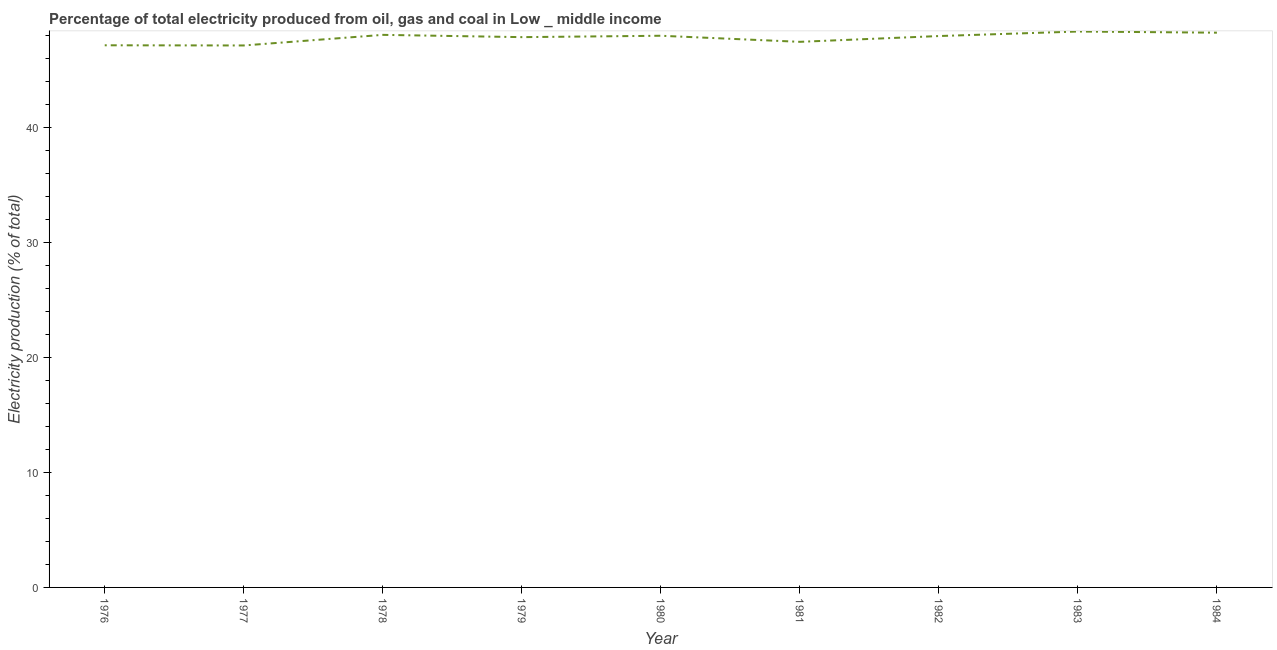What is the electricity production in 1981?
Give a very brief answer. 47.49. Across all years, what is the maximum electricity production?
Provide a succinct answer. 48.39. Across all years, what is the minimum electricity production?
Your response must be concise. 47.17. In which year was the electricity production minimum?
Your answer should be very brief. 1977. What is the sum of the electricity production?
Provide a succinct answer. 430.52. What is the difference between the electricity production in 1978 and 1983?
Your answer should be compact. -0.29. What is the average electricity production per year?
Make the answer very short. 47.84. What is the median electricity production?
Your response must be concise. 47.99. In how many years, is the electricity production greater than 44 %?
Give a very brief answer. 9. What is the ratio of the electricity production in 1980 to that in 1983?
Give a very brief answer. 0.99. Is the electricity production in 1976 less than that in 1984?
Your answer should be compact. Yes. Is the difference between the electricity production in 1976 and 1980 greater than the difference between any two years?
Your answer should be very brief. No. What is the difference between the highest and the second highest electricity production?
Your answer should be very brief. 0.1. Is the sum of the electricity production in 1977 and 1984 greater than the maximum electricity production across all years?
Give a very brief answer. Yes. What is the difference between the highest and the lowest electricity production?
Ensure brevity in your answer.  1.21. In how many years, is the electricity production greater than the average electricity production taken over all years?
Offer a very short reply. 6. Does the electricity production monotonically increase over the years?
Your answer should be very brief. No. What is the difference between two consecutive major ticks on the Y-axis?
Offer a terse response. 10. Does the graph contain grids?
Your answer should be very brief. No. What is the title of the graph?
Your answer should be very brief. Percentage of total electricity produced from oil, gas and coal in Low _ middle income. What is the label or title of the X-axis?
Ensure brevity in your answer.  Year. What is the label or title of the Y-axis?
Offer a very short reply. Electricity production (% of total). What is the Electricity production (% of total) in 1976?
Offer a very short reply. 47.19. What is the Electricity production (% of total) of 1977?
Keep it short and to the point. 47.17. What is the Electricity production (% of total) in 1978?
Ensure brevity in your answer.  48.09. What is the Electricity production (% of total) of 1979?
Ensure brevity in your answer.  47.9. What is the Electricity production (% of total) of 1980?
Give a very brief answer. 48.02. What is the Electricity production (% of total) in 1981?
Provide a succinct answer. 47.49. What is the Electricity production (% of total) in 1982?
Ensure brevity in your answer.  47.99. What is the Electricity production (% of total) in 1983?
Make the answer very short. 48.39. What is the Electricity production (% of total) of 1984?
Offer a very short reply. 48.28. What is the difference between the Electricity production (% of total) in 1976 and 1977?
Your response must be concise. 0.02. What is the difference between the Electricity production (% of total) in 1976 and 1978?
Your response must be concise. -0.91. What is the difference between the Electricity production (% of total) in 1976 and 1979?
Offer a very short reply. -0.71. What is the difference between the Electricity production (% of total) in 1976 and 1980?
Offer a very short reply. -0.83. What is the difference between the Electricity production (% of total) in 1976 and 1981?
Your answer should be very brief. -0.3. What is the difference between the Electricity production (% of total) in 1976 and 1982?
Your response must be concise. -0.8. What is the difference between the Electricity production (% of total) in 1976 and 1983?
Your response must be concise. -1.2. What is the difference between the Electricity production (% of total) in 1976 and 1984?
Your answer should be compact. -1.1. What is the difference between the Electricity production (% of total) in 1977 and 1978?
Your response must be concise. -0.92. What is the difference between the Electricity production (% of total) in 1977 and 1979?
Your answer should be very brief. -0.72. What is the difference between the Electricity production (% of total) in 1977 and 1980?
Ensure brevity in your answer.  -0.85. What is the difference between the Electricity production (% of total) in 1977 and 1981?
Offer a terse response. -0.32. What is the difference between the Electricity production (% of total) in 1977 and 1982?
Your answer should be compact. -0.82. What is the difference between the Electricity production (% of total) in 1977 and 1983?
Make the answer very short. -1.21. What is the difference between the Electricity production (% of total) in 1977 and 1984?
Make the answer very short. -1.11. What is the difference between the Electricity production (% of total) in 1978 and 1979?
Offer a terse response. 0.2. What is the difference between the Electricity production (% of total) in 1978 and 1980?
Make the answer very short. 0.08. What is the difference between the Electricity production (% of total) in 1978 and 1981?
Ensure brevity in your answer.  0.61. What is the difference between the Electricity production (% of total) in 1978 and 1982?
Keep it short and to the point. 0.1. What is the difference between the Electricity production (% of total) in 1978 and 1983?
Make the answer very short. -0.29. What is the difference between the Electricity production (% of total) in 1978 and 1984?
Keep it short and to the point. -0.19. What is the difference between the Electricity production (% of total) in 1979 and 1980?
Give a very brief answer. -0.12. What is the difference between the Electricity production (% of total) in 1979 and 1981?
Keep it short and to the point. 0.41. What is the difference between the Electricity production (% of total) in 1979 and 1982?
Your answer should be very brief. -0.1. What is the difference between the Electricity production (% of total) in 1979 and 1983?
Provide a succinct answer. -0.49. What is the difference between the Electricity production (% of total) in 1979 and 1984?
Give a very brief answer. -0.39. What is the difference between the Electricity production (% of total) in 1980 and 1981?
Provide a short and direct response. 0.53. What is the difference between the Electricity production (% of total) in 1980 and 1982?
Your answer should be compact. 0.03. What is the difference between the Electricity production (% of total) in 1980 and 1983?
Your answer should be compact. -0.37. What is the difference between the Electricity production (% of total) in 1980 and 1984?
Your answer should be compact. -0.27. What is the difference between the Electricity production (% of total) in 1981 and 1982?
Offer a terse response. -0.5. What is the difference between the Electricity production (% of total) in 1981 and 1983?
Make the answer very short. -0.9. What is the difference between the Electricity production (% of total) in 1981 and 1984?
Offer a very short reply. -0.8. What is the difference between the Electricity production (% of total) in 1982 and 1983?
Offer a very short reply. -0.39. What is the difference between the Electricity production (% of total) in 1982 and 1984?
Your answer should be compact. -0.29. What is the difference between the Electricity production (% of total) in 1983 and 1984?
Your answer should be compact. 0.1. What is the ratio of the Electricity production (% of total) in 1976 to that in 1979?
Ensure brevity in your answer.  0.98. What is the ratio of the Electricity production (% of total) in 1976 to that in 1980?
Your answer should be compact. 0.98. What is the ratio of the Electricity production (% of total) in 1976 to that in 1982?
Provide a short and direct response. 0.98. What is the ratio of the Electricity production (% of total) in 1976 to that in 1984?
Your answer should be very brief. 0.98. What is the ratio of the Electricity production (% of total) in 1977 to that in 1979?
Offer a terse response. 0.98. What is the ratio of the Electricity production (% of total) in 1977 to that in 1981?
Make the answer very short. 0.99. What is the ratio of the Electricity production (% of total) in 1977 to that in 1983?
Provide a short and direct response. 0.97. What is the ratio of the Electricity production (% of total) in 1978 to that in 1979?
Ensure brevity in your answer.  1. What is the ratio of the Electricity production (% of total) in 1978 to that in 1981?
Make the answer very short. 1.01. What is the ratio of the Electricity production (% of total) in 1978 to that in 1983?
Provide a short and direct response. 0.99. What is the ratio of the Electricity production (% of total) in 1979 to that in 1981?
Make the answer very short. 1.01. What is the ratio of the Electricity production (% of total) in 1979 to that in 1982?
Provide a short and direct response. 1. What is the ratio of the Electricity production (% of total) in 1979 to that in 1983?
Give a very brief answer. 0.99. What is the ratio of the Electricity production (% of total) in 1980 to that in 1981?
Offer a very short reply. 1.01. What is the ratio of the Electricity production (% of total) in 1980 to that in 1984?
Make the answer very short. 0.99. What is the ratio of the Electricity production (% of total) in 1981 to that in 1983?
Keep it short and to the point. 0.98. What is the ratio of the Electricity production (% of total) in 1981 to that in 1984?
Keep it short and to the point. 0.98. What is the ratio of the Electricity production (% of total) in 1982 to that in 1984?
Make the answer very short. 0.99. 